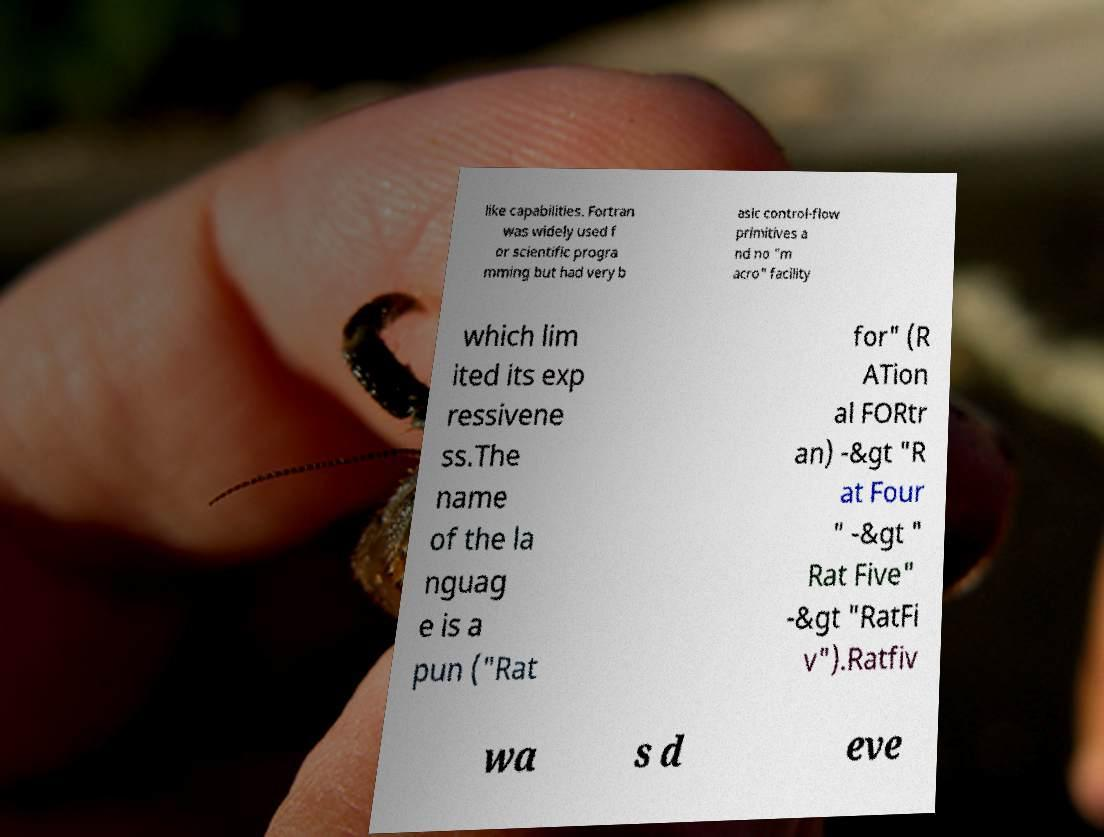Could you extract and type out the text from this image? like capabilities. Fortran was widely used f or scientific progra mming but had very b asic control-flow primitives a nd no "m acro" facility which lim ited its exp ressivene ss.The name of the la nguag e is a pun ("Rat for" (R ATion al FORtr an) -&gt "R at Four " -&gt " Rat Five" -&gt "RatFi v").Ratfiv wa s d eve 